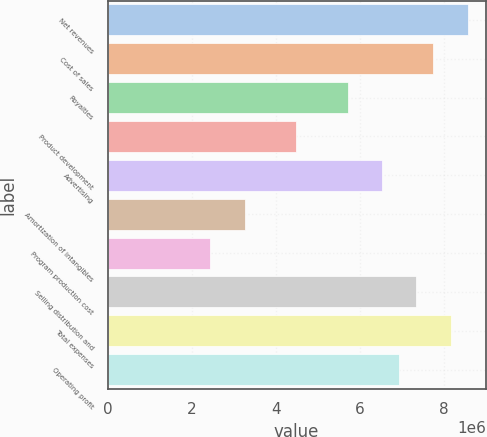Convert chart. <chart><loc_0><loc_0><loc_500><loc_500><bar_chart><fcel>Net revenues<fcel>Cost of sales<fcel>Royalties<fcel>Product development<fcel>Advertising<fcel>Amortization of intangibles<fcel>Program production cost<fcel>Selling distribution and<fcel>Total expenses<fcel>Operating profit<nl><fcel>8.57253e+06<fcel>7.7561e+06<fcel>5.71502e+06<fcel>4.49037e+06<fcel>6.53145e+06<fcel>3.26573e+06<fcel>2.44929e+06<fcel>7.34788e+06<fcel>8.16431e+06<fcel>6.93967e+06<nl></chart> 